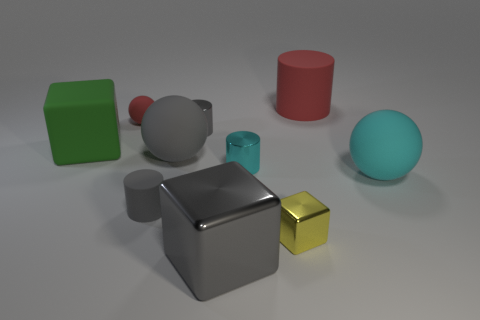Subtract all cyan balls. How many balls are left? 2 Subtract all balls. How many objects are left? 7 Subtract all gray blocks. How many gray cylinders are left? 2 Subtract all large gray spheres. Subtract all small metal cubes. How many objects are left? 8 Add 4 gray cylinders. How many gray cylinders are left? 6 Add 6 green cubes. How many green cubes exist? 7 Subtract all cyan cylinders. How many cylinders are left? 3 Subtract 0 blue balls. How many objects are left? 10 Subtract all brown cubes. Subtract all red balls. How many cubes are left? 3 